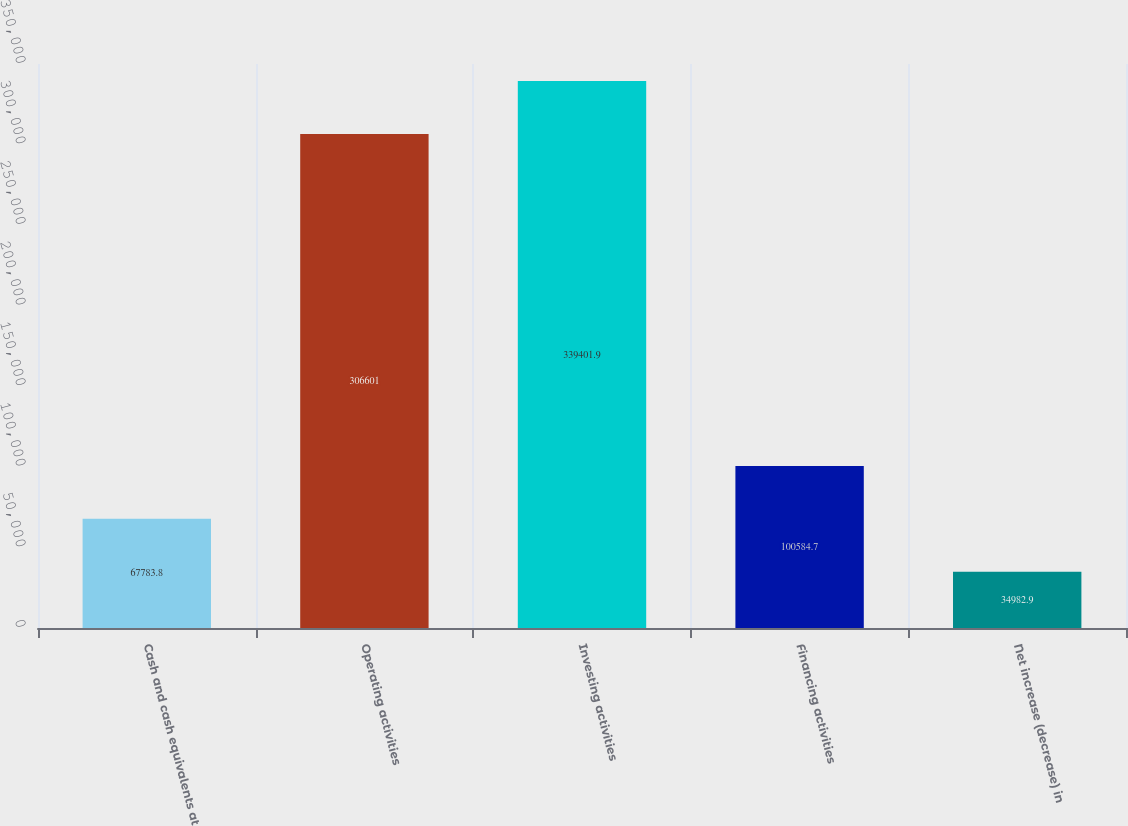Convert chart. <chart><loc_0><loc_0><loc_500><loc_500><bar_chart><fcel>Cash and cash equivalents at<fcel>Operating activities<fcel>Investing activities<fcel>Financing activities<fcel>Net increase (decrease) in<nl><fcel>67783.8<fcel>306601<fcel>339402<fcel>100585<fcel>34982.9<nl></chart> 